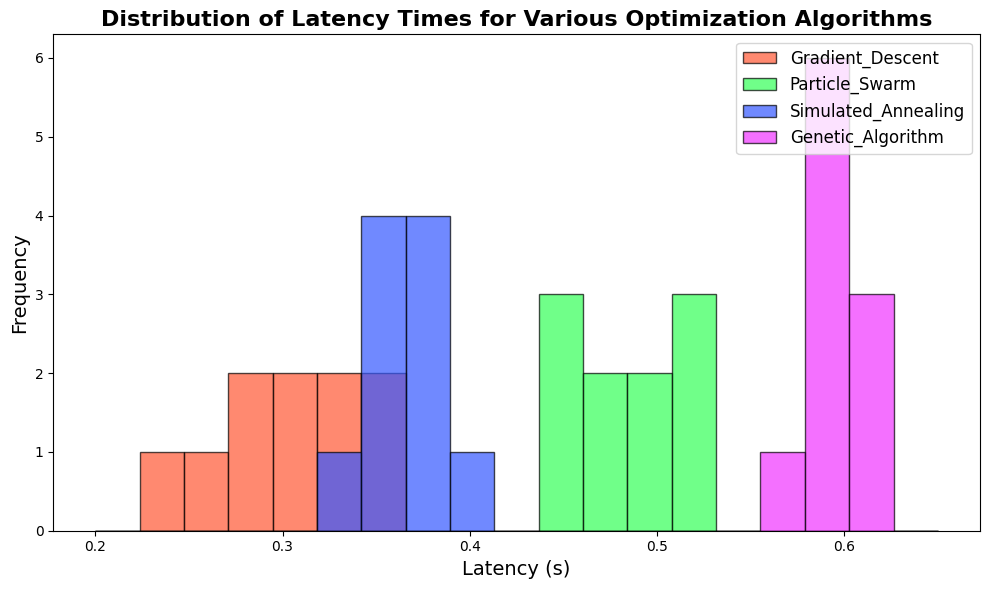What's the average latency time for Gradient Descent? Sum all latency times for Gradient Descent (0.23 + 0.27 + 0.35 + 0.32 + 0.31 + 0.29 + 0.34 + 0.36 + 0.28 + 0.30) = 3.05, divide by the number of data points (10), so the average is 3.05 / 10 = 0.305
Answer: 0.305 Which algorithm has the widest distribution of latency times? By looking at the histogram, the algorithm with bars spread over the widest range of latency values shows the widest distribution. Particle Swarm ranges from 0.44 to 0.53 seconds, wider compared to other algorithms.
Answer: Particle Swarm How many algorithms have a latency time peak between 0.30 and 0.35 seconds? By observing the histogram bars, Gradient Descent and Simulated Annealing have their most frequent values (peak height) in the 0.30 - 0.35 seconds range, with noticeable bars within this interval.
Answer: 2 Which algorithm shows the highest latency times? By looking at the histogram, Genetic Algorithm has bars highest on the latency scale, ranging between 0.57 and 0.62 seconds. This is clearly higher than the other algorithms.
Answer: Genetic Algorithm Is there an algorithm with a latency time below 0.25 seconds? By examining the lowest latency time bins in the histogram, only Gradient Descent has data points in latency times below 0.25 seconds.
Answer: Yes Which algorithm has a tighter grouping of latency times, Simulated Annealing or Genetic Algorithm? By looking at the spread of the histogram bars, Simulated Annealing clusters more tightly around 0.35 to 0.39 seconds, whereas Genetic Algorithm spans from 0.57 to 0.62 seconds. Thus, Simulated Annealing has a tighter grouping.
Answer: Simulated Annealing Compare the highest frequency of latency times between Particle Swarm and Simulated Annealing. Which one is higher? By comparing the tallest bars (frequency peaks) in the histograms for both algorithms, Particle Swarm has higher bars indicating a higher frequency of latency times around 0.45 to 0.52 seconds compared to Simulated Annealing which peaks around 0.36 to 0.39.
Answer: Particle Swarm Which algorithm shows more latency variance, Gradient Descent or Particle Swarm? By comparing the spread of the histograms, Particle Swarm shows a wider range of latency times (0.44 to 0.53 seconds) compared to Gradient Descent (0.23 to 0.36 seconds), indicating higher variance.
Answer: Particle Swarm Is the median latency time for Simulated Annealing within the 0.35 to 0.38 second range? By looking at the histogram's bars for Simulated Annealing, the central values around 0.35 and 0.38 seconds contain the median of the data points. Hence, the median falls within this range.
Answer: Yes 